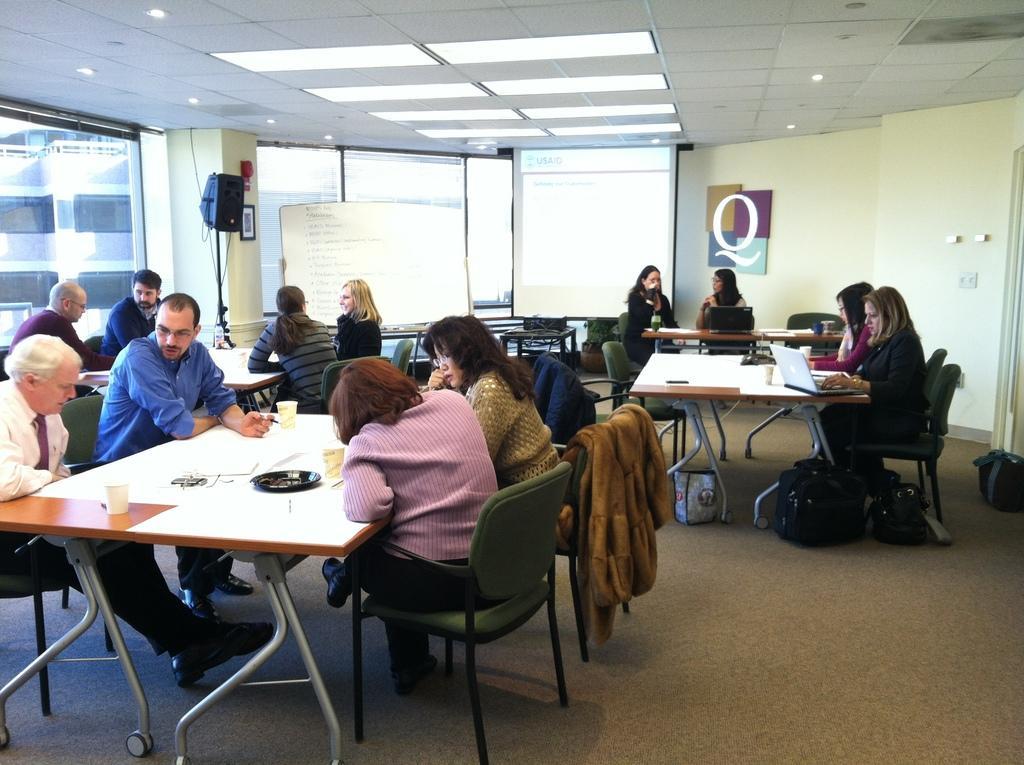How would you summarize this image in a sentence or two? This image is clicked in a room there are tables and chairs. People are sitting on chairs around the tables. On the tables there are glasses, plates, laptops. There is a speaker on the left side. There are lights on the top. There is a whiteboard in the back side. 